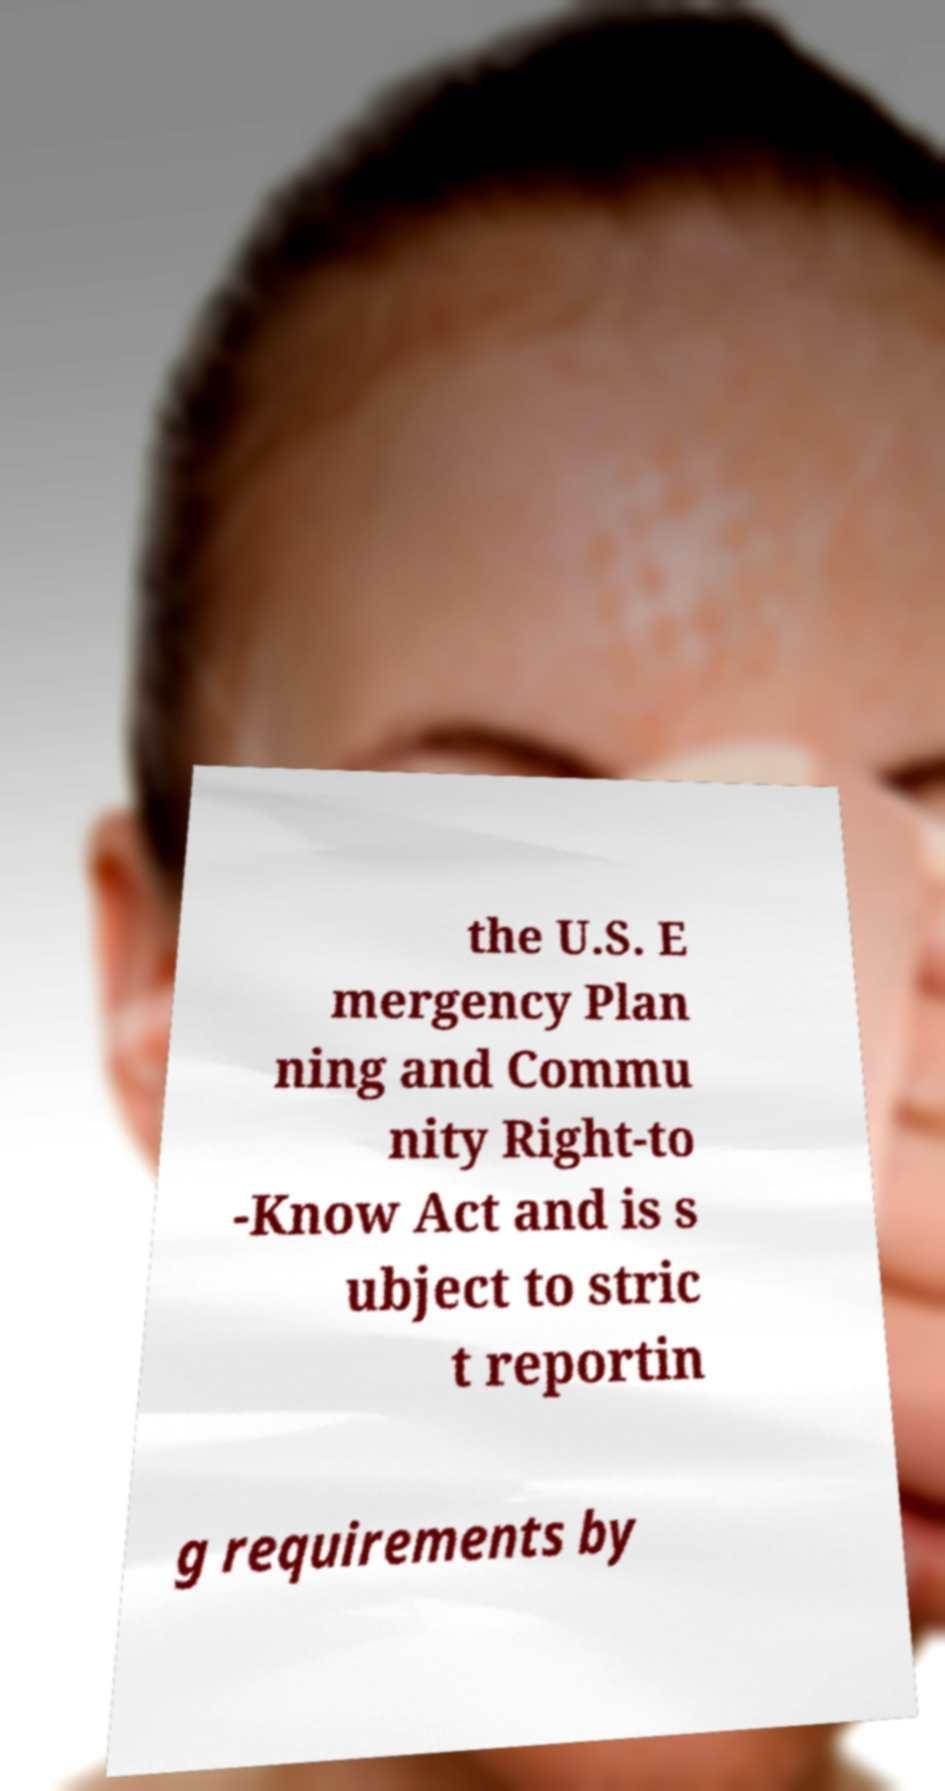Please identify and transcribe the text found in this image. the U.S. E mergency Plan ning and Commu nity Right-to -Know Act and is s ubject to stric t reportin g requirements by 